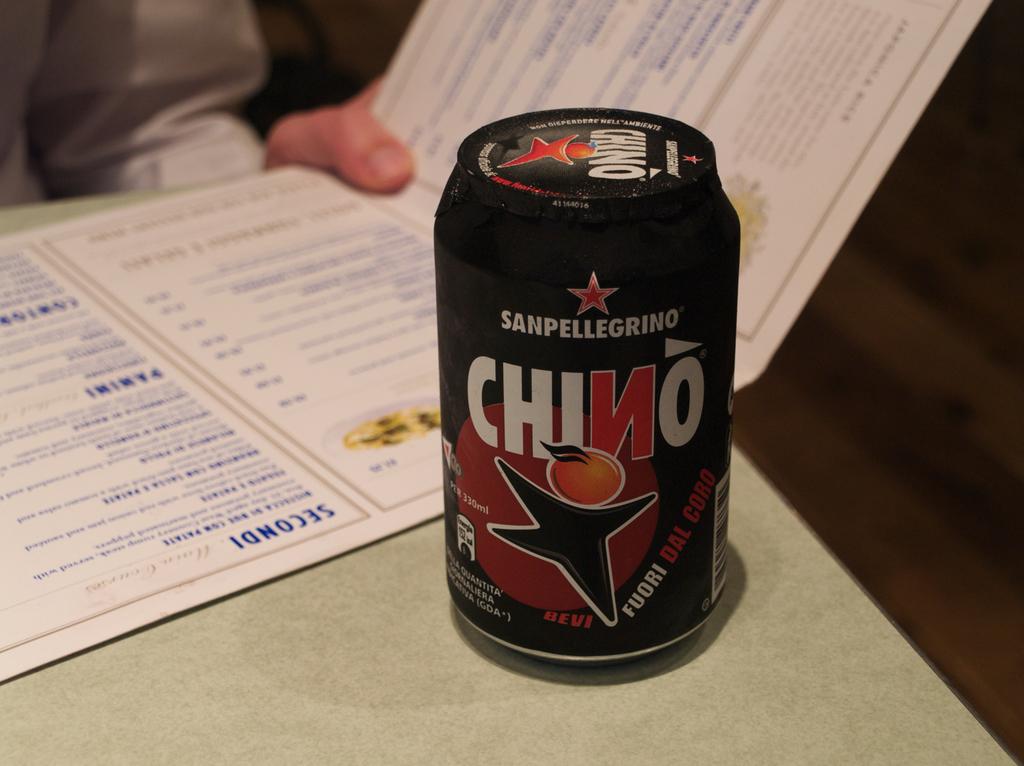What is the name on this can?
Make the answer very short. Chino. 